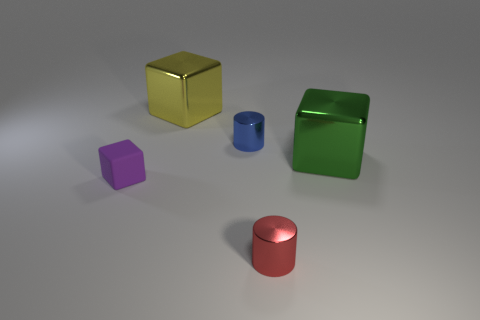Add 3 shiny objects. How many objects exist? 8 Subtract all cubes. How many objects are left? 2 Subtract 0 cyan cylinders. How many objects are left? 5 Subtract all shiny blocks. Subtract all tiny blue metallic objects. How many objects are left? 2 Add 1 tiny purple things. How many tiny purple things are left? 2 Add 5 large rubber spheres. How many large rubber spheres exist? 5 